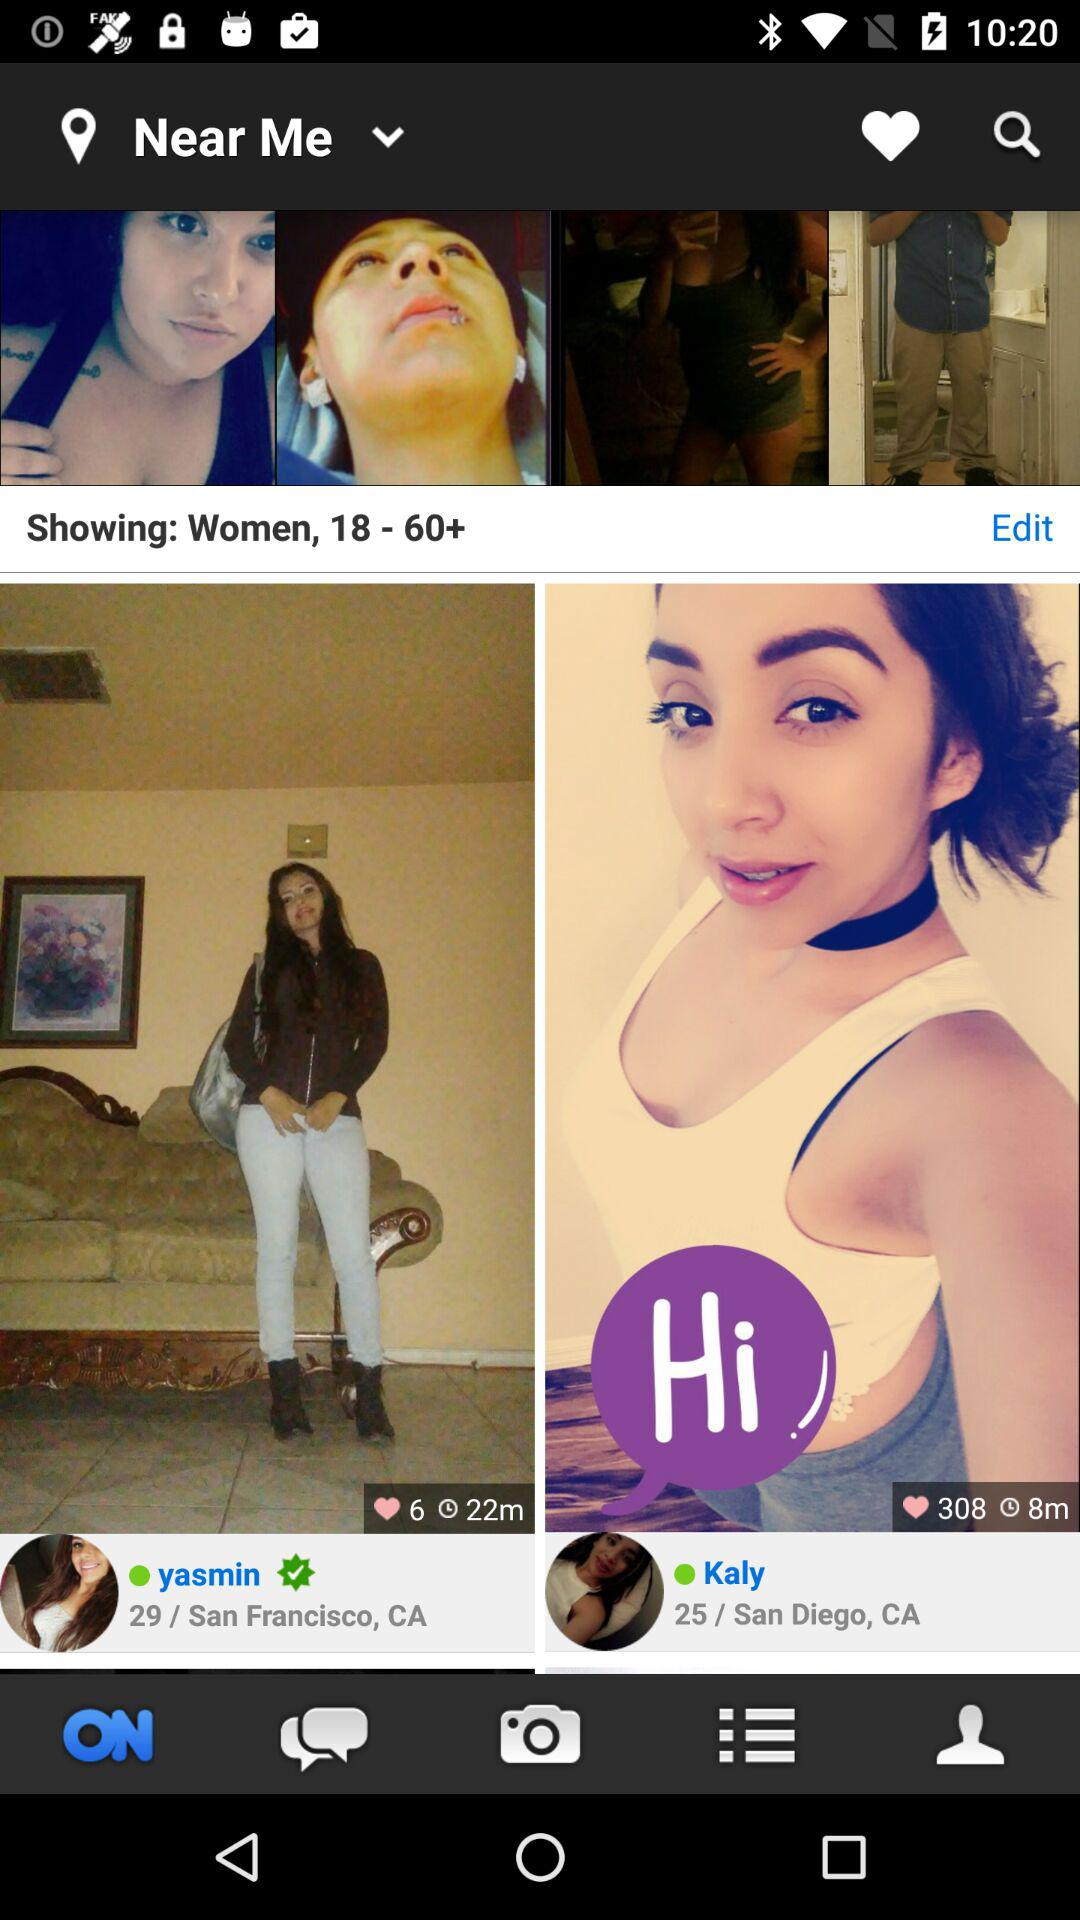How many minutes are displayed in Yasmin's profile? The post was posted 22 minutes ago. 